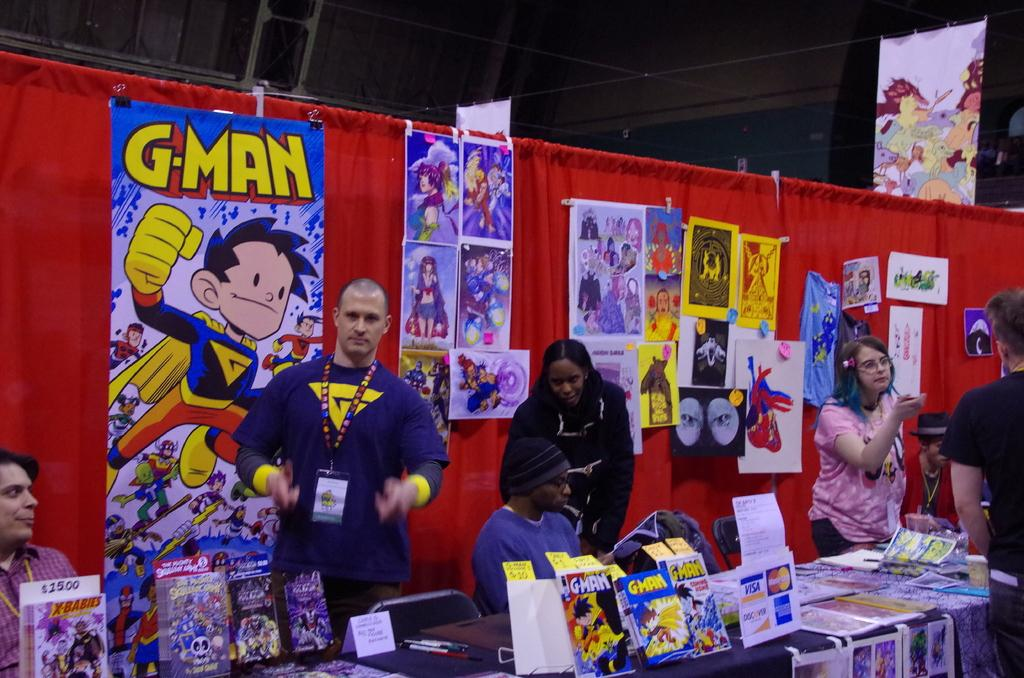<image>
Create a compact narrative representing the image presented. G Man comic books and magazines on a table at a convention. 